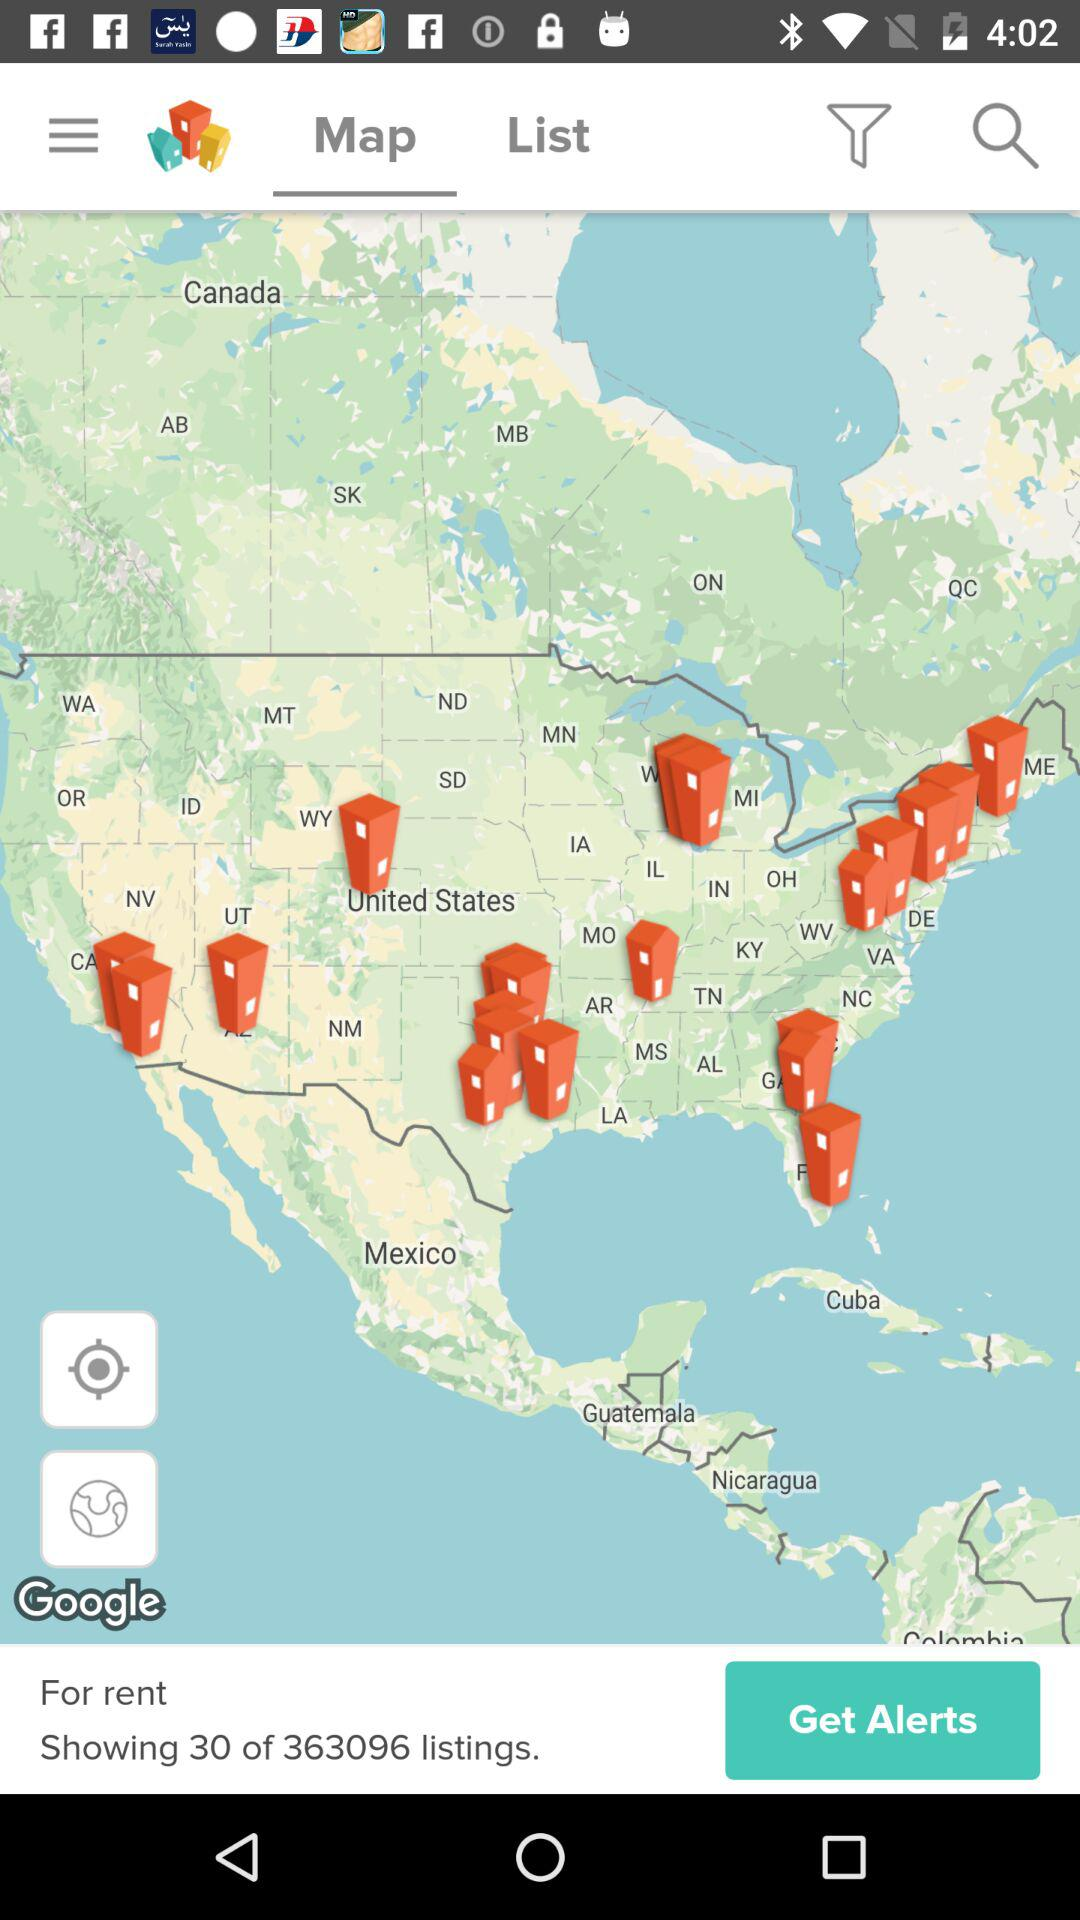How many listings in total are there? There are 363096 listings in total. 